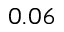Convert formula to latex. <formula><loc_0><loc_0><loc_500><loc_500>0 . 0 6</formula> 